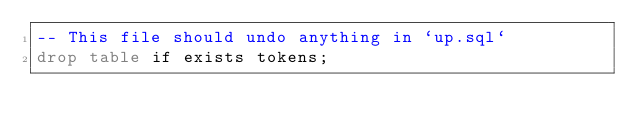<code> <loc_0><loc_0><loc_500><loc_500><_SQL_>-- This file should undo anything in `up.sql`
drop table if exists tokens;
</code> 